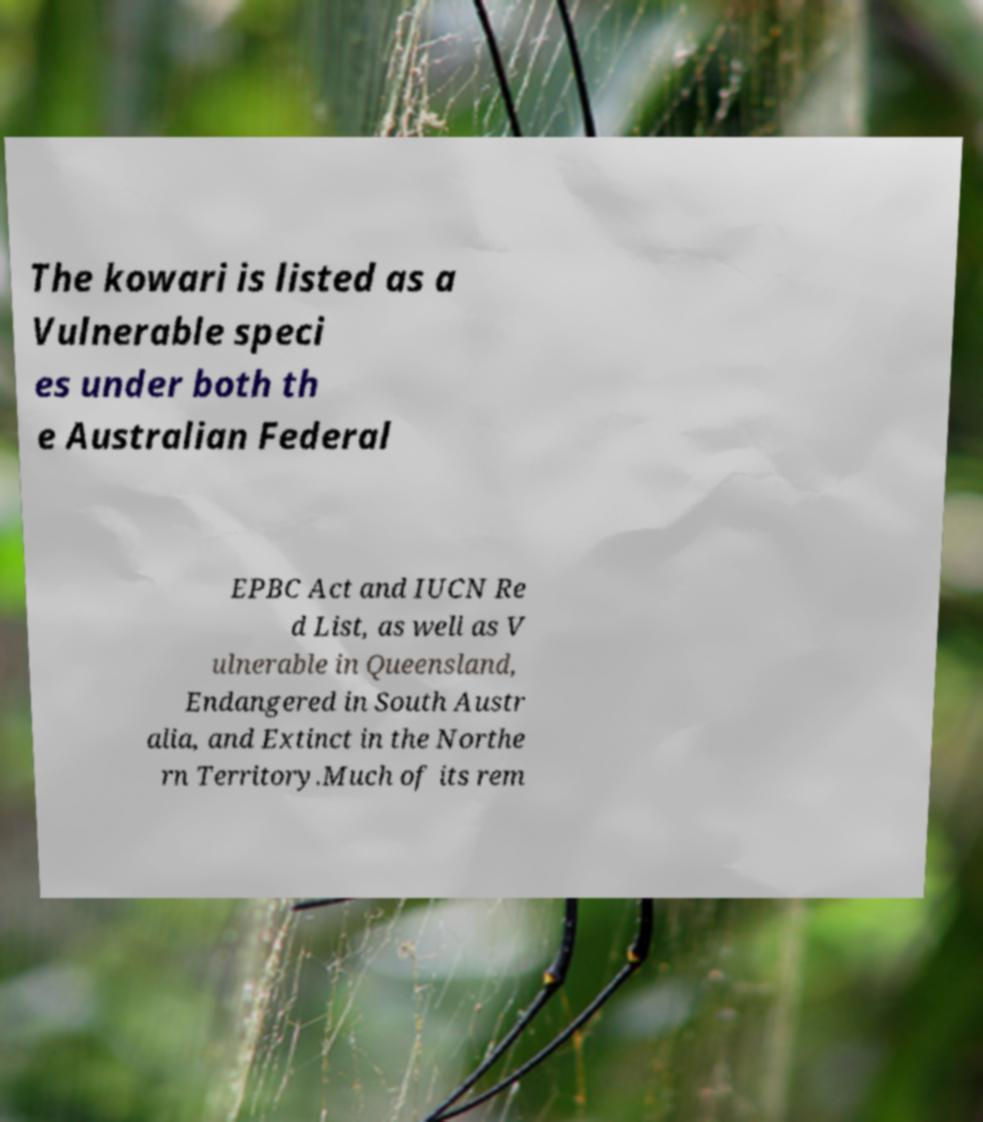Please identify and transcribe the text found in this image. The kowari is listed as a Vulnerable speci es under both th e Australian Federal EPBC Act and IUCN Re d List, as well as V ulnerable in Queensland, Endangered in South Austr alia, and Extinct in the Northe rn Territory.Much of its rem 